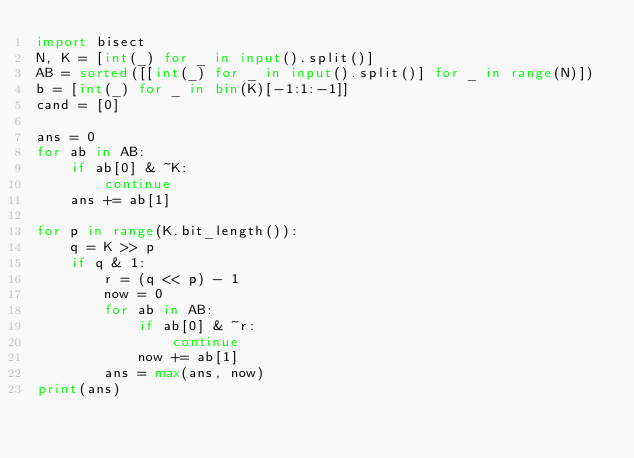<code> <loc_0><loc_0><loc_500><loc_500><_Python_>import bisect
N, K = [int(_) for _ in input().split()]
AB = sorted([[int(_) for _ in input().split()] for _ in range(N)])
b = [int(_) for _ in bin(K)[-1:1:-1]]
cand = [0]

ans = 0
for ab in AB:
    if ab[0] & ~K:
        continue
    ans += ab[1]

for p in range(K.bit_length()):
    q = K >> p
    if q & 1:
        r = (q << p) - 1
        now = 0
        for ab in AB:
            if ab[0] & ~r:
                continue
            now += ab[1]
        ans = max(ans, now)
print(ans)
</code> 